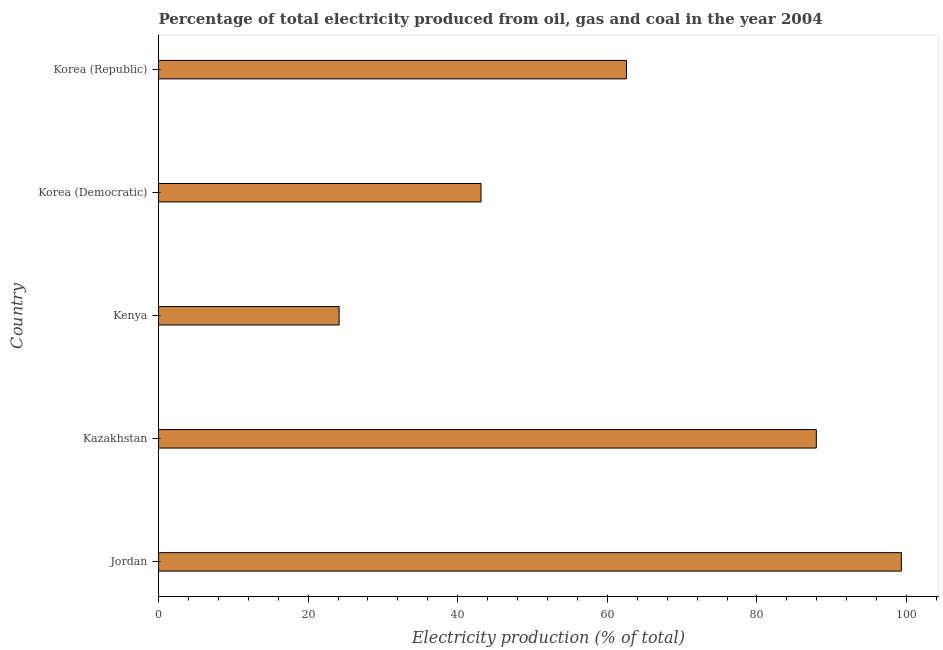Does the graph contain any zero values?
Offer a very short reply. No. What is the title of the graph?
Offer a terse response. Percentage of total electricity produced from oil, gas and coal in the year 2004. What is the label or title of the X-axis?
Ensure brevity in your answer.  Electricity production (% of total). What is the electricity production in Jordan?
Keep it short and to the point. 99.31. Across all countries, what is the maximum electricity production?
Make the answer very short. 99.31. Across all countries, what is the minimum electricity production?
Ensure brevity in your answer.  24.14. In which country was the electricity production maximum?
Your answer should be very brief. Jordan. In which country was the electricity production minimum?
Keep it short and to the point. Kenya. What is the sum of the electricity production?
Offer a terse response. 317.07. What is the difference between the electricity production in Kazakhstan and Korea (Republic)?
Your answer should be compact. 25.39. What is the average electricity production per country?
Your answer should be compact. 63.41. What is the median electricity production?
Your response must be concise. 62.56. In how many countries, is the electricity production greater than 8 %?
Provide a succinct answer. 5. What is the ratio of the electricity production in Kazakhstan to that in Kenya?
Your answer should be compact. 3.64. Is the electricity production in Jordan less than that in Korea (Democratic)?
Make the answer very short. No. What is the difference between the highest and the second highest electricity production?
Provide a succinct answer. 11.37. What is the difference between the highest and the lowest electricity production?
Provide a short and direct response. 75.17. How many bars are there?
Keep it short and to the point. 5. What is the difference between two consecutive major ticks on the X-axis?
Keep it short and to the point. 20. Are the values on the major ticks of X-axis written in scientific E-notation?
Give a very brief answer. No. What is the Electricity production (% of total) of Jordan?
Provide a short and direct response. 99.31. What is the Electricity production (% of total) in Kazakhstan?
Provide a short and direct response. 87.94. What is the Electricity production (% of total) of Kenya?
Provide a short and direct response. 24.14. What is the Electricity production (% of total) in Korea (Democratic)?
Your answer should be very brief. 43.11. What is the Electricity production (% of total) in Korea (Republic)?
Give a very brief answer. 62.56. What is the difference between the Electricity production (% of total) in Jordan and Kazakhstan?
Offer a terse response. 11.36. What is the difference between the Electricity production (% of total) in Jordan and Kenya?
Offer a terse response. 75.17. What is the difference between the Electricity production (% of total) in Jordan and Korea (Democratic)?
Provide a short and direct response. 56.19. What is the difference between the Electricity production (% of total) in Jordan and Korea (Republic)?
Provide a succinct answer. 36.75. What is the difference between the Electricity production (% of total) in Kazakhstan and Kenya?
Your answer should be compact. 63.8. What is the difference between the Electricity production (% of total) in Kazakhstan and Korea (Democratic)?
Ensure brevity in your answer.  44.83. What is the difference between the Electricity production (% of total) in Kazakhstan and Korea (Republic)?
Your answer should be compact. 25.39. What is the difference between the Electricity production (% of total) in Kenya and Korea (Democratic)?
Your response must be concise. -18.97. What is the difference between the Electricity production (% of total) in Kenya and Korea (Republic)?
Give a very brief answer. -38.42. What is the difference between the Electricity production (% of total) in Korea (Democratic) and Korea (Republic)?
Make the answer very short. -19.44. What is the ratio of the Electricity production (% of total) in Jordan to that in Kazakhstan?
Make the answer very short. 1.13. What is the ratio of the Electricity production (% of total) in Jordan to that in Kenya?
Provide a succinct answer. 4.11. What is the ratio of the Electricity production (% of total) in Jordan to that in Korea (Democratic)?
Offer a terse response. 2.3. What is the ratio of the Electricity production (% of total) in Jordan to that in Korea (Republic)?
Your answer should be compact. 1.59. What is the ratio of the Electricity production (% of total) in Kazakhstan to that in Kenya?
Keep it short and to the point. 3.64. What is the ratio of the Electricity production (% of total) in Kazakhstan to that in Korea (Democratic)?
Provide a short and direct response. 2.04. What is the ratio of the Electricity production (% of total) in Kazakhstan to that in Korea (Republic)?
Make the answer very short. 1.41. What is the ratio of the Electricity production (% of total) in Kenya to that in Korea (Democratic)?
Your answer should be compact. 0.56. What is the ratio of the Electricity production (% of total) in Kenya to that in Korea (Republic)?
Provide a succinct answer. 0.39. What is the ratio of the Electricity production (% of total) in Korea (Democratic) to that in Korea (Republic)?
Give a very brief answer. 0.69. 